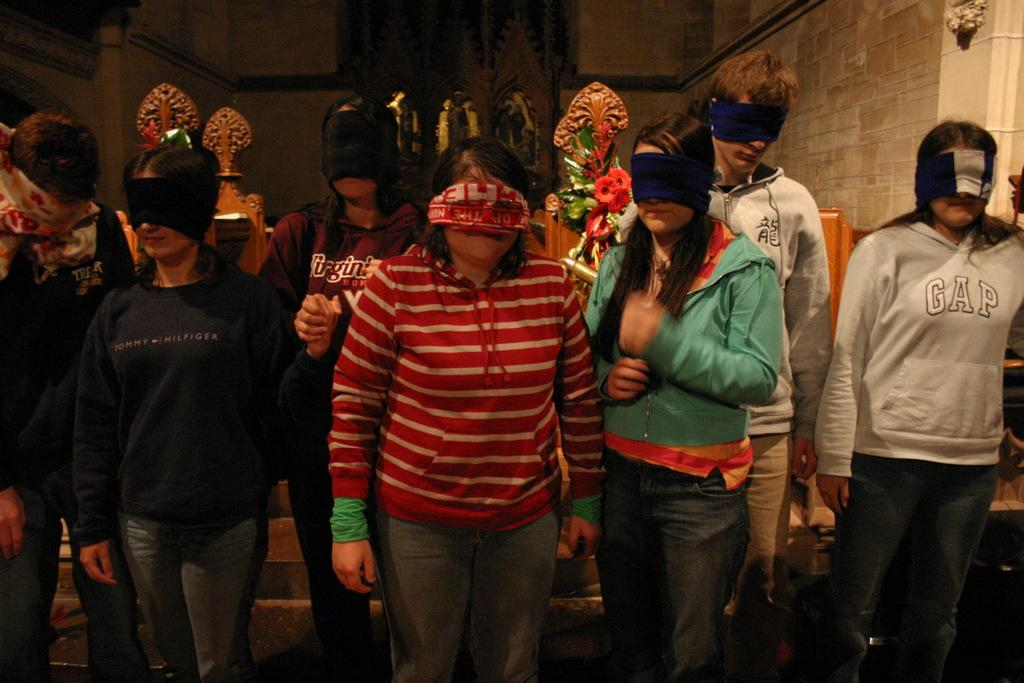What is happening with the persons in the image? The persons in the image are standing and covering their eyes with some clothes. What can be seen in the background of the image? There is a wall in the background of the image. What type of haircut is being given to the person on the left in the image? There is no haircut being given in the image; the persons are covering their eyes with some clothes. What is being served on the plate in the image? There is no plate present in the image. 